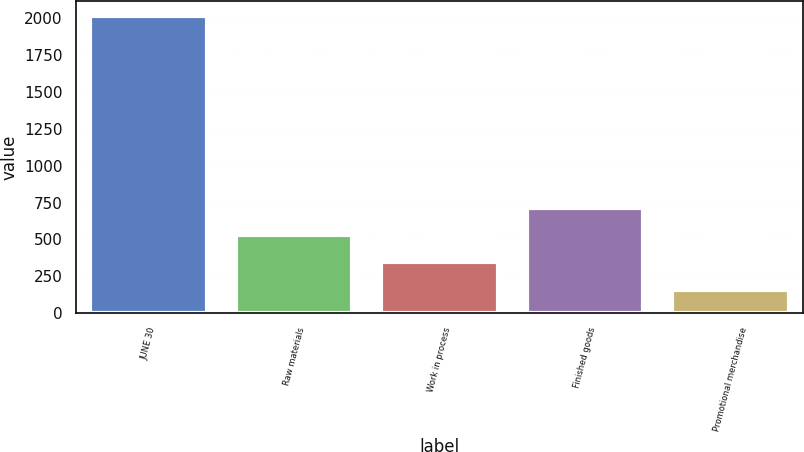<chart> <loc_0><loc_0><loc_500><loc_500><bar_chart><fcel>JUNE 30<fcel>Raw materials<fcel>Work in process<fcel>Finished goods<fcel>Promotional merchandise<nl><fcel>2015<fcel>530.12<fcel>344.51<fcel>715.73<fcel>158.9<nl></chart> 